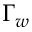<formula> <loc_0><loc_0><loc_500><loc_500>\Gamma _ { w }</formula> 